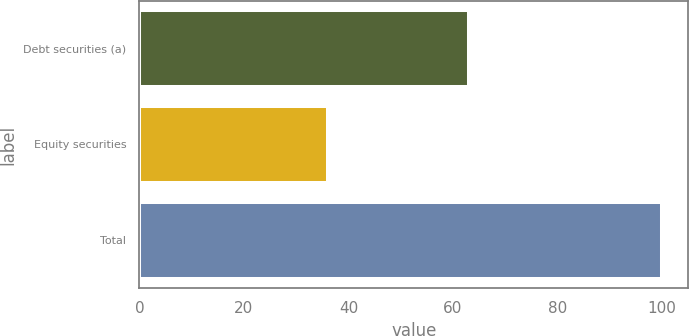<chart> <loc_0><loc_0><loc_500><loc_500><bar_chart><fcel>Debt securities (a)<fcel>Equity securities<fcel>Total<nl><fcel>63<fcel>36<fcel>100<nl></chart> 